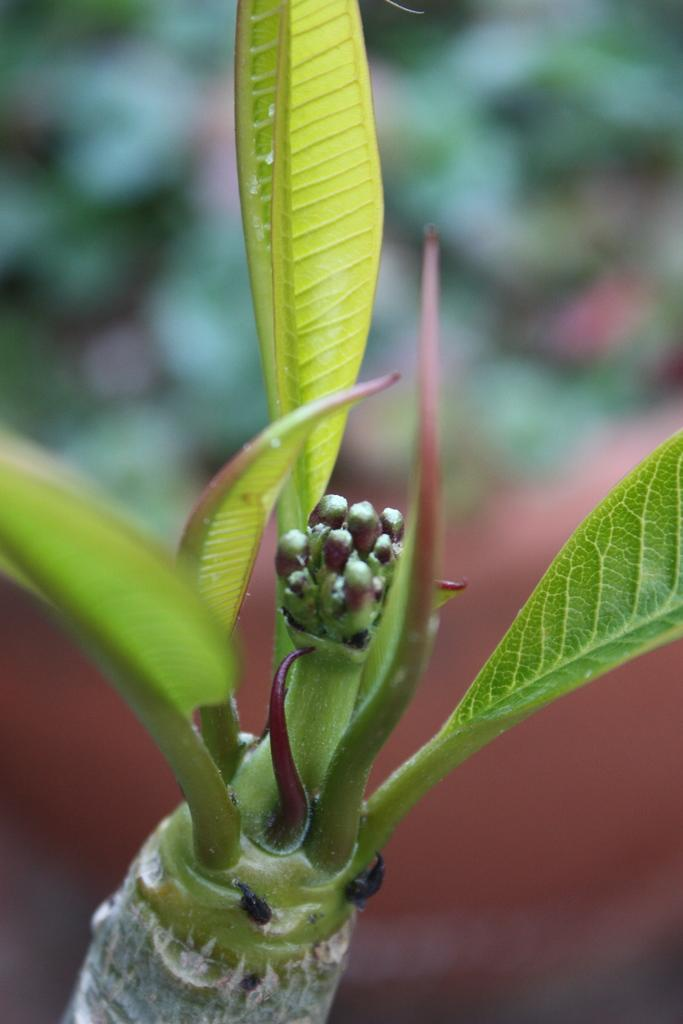What type of living organism is present in the image? There is a plant in the image. What is the plant placed in? There is a flowerpot in the image. Can you describe the background of the image? The background of the image is blurred. What verse can be heard recited by the children in the image? There are no children or verses present in the image; it features a plant in a flowerpot with a blurred background. 